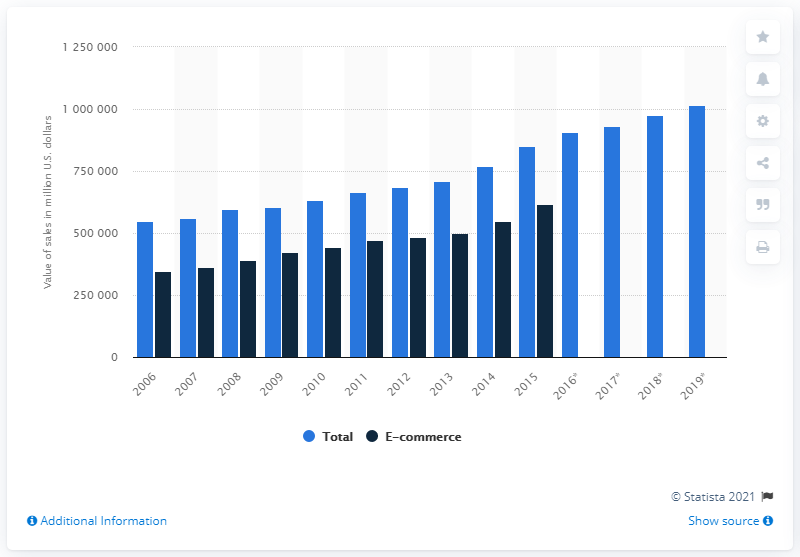Draw attention to some important aspects in this diagram. The wholesale e-commerce sales value of drugs and druggists' sundries from 2006 to 2019 was approximately 61,589,100. 